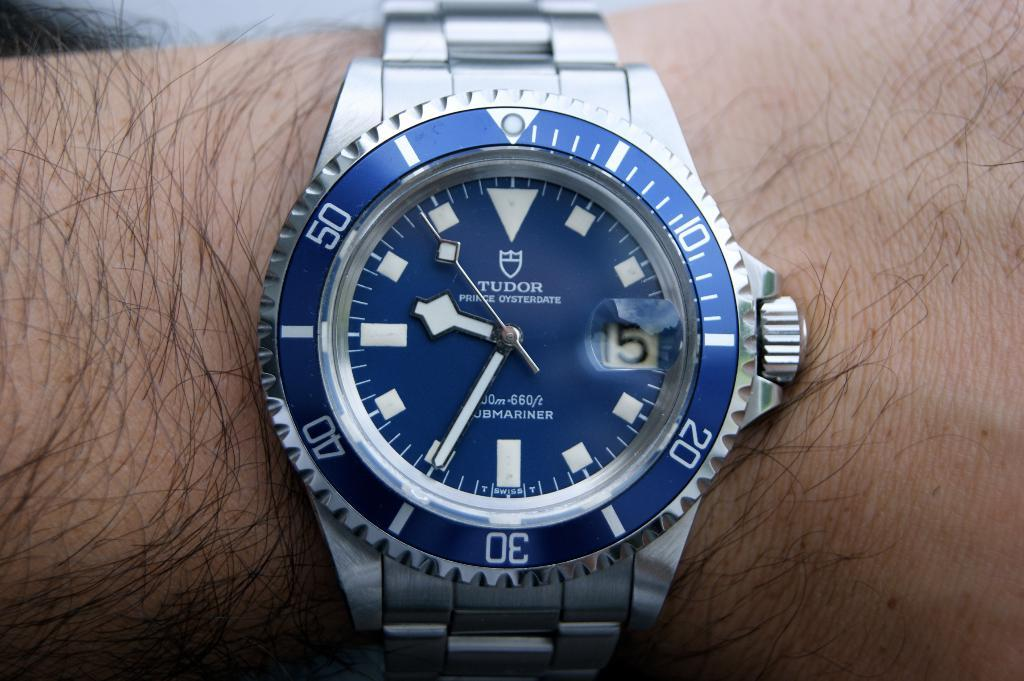<image>
Create a compact narrative representing the image presented. A Tudor brand wristwatch in silver and blue. 